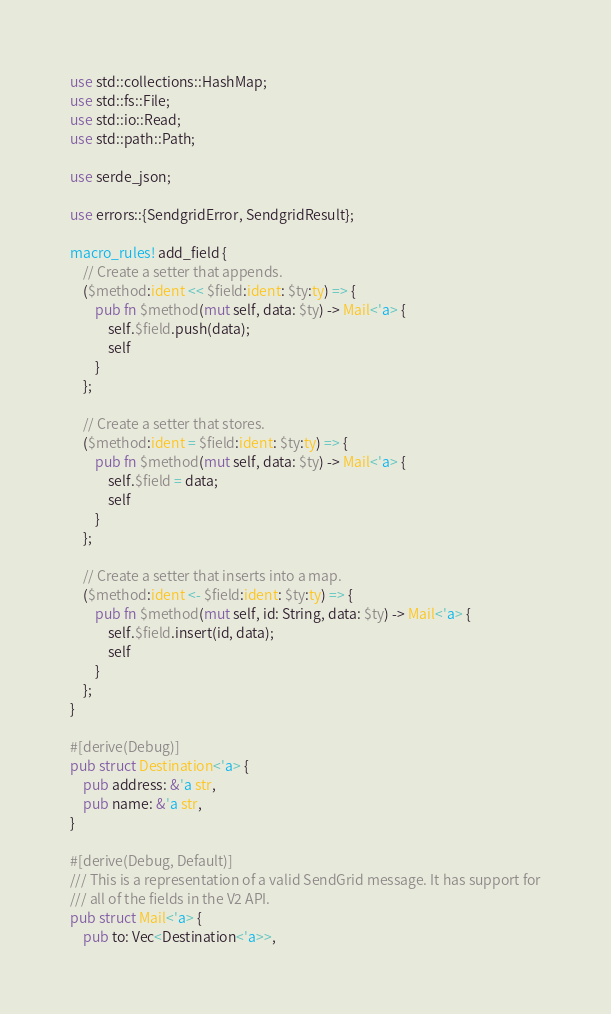Convert code to text. <code><loc_0><loc_0><loc_500><loc_500><_Rust_>use std::collections::HashMap;
use std::fs::File;
use std::io::Read;
use std::path::Path;

use serde_json;

use errors::{SendgridError, SendgridResult};

macro_rules! add_field {
    // Create a setter that appends.
    ($method:ident << $field:ident: $ty:ty) => {
        pub fn $method(mut self, data: $ty) -> Mail<'a> {
            self.$field.push(data);
            self
        }
    };

    // Create a setter that stores.
    ($method:ident = $field:ident: $ty:ty) => {
        pub fn $method(mut self, data: $ty) -> Mail<'a> {
            self.$field = data;
            self
        }
    };

    // Create a setter that inserts into a map.
    ($method:ident <- $field:ident: $ty:ty) => {
        pub fn $method(mut self, id: String, data: $ty) -> Mail<'a> {
            self.$field.insert(id, data);
            self
        }
    };
}

#[derive(Debug)]
pub struct Destination<'a> {
    pub address: &'a str,
    pub name: &'a str,
}

#[derive(Debug, Default)]
/// This is a representation of a valid SendGrid message. It has support for
/// all of the fields in the V2 API.
pub struct Mail<'a> {
    pub to: Vec<Destination<'a>>,</code> 